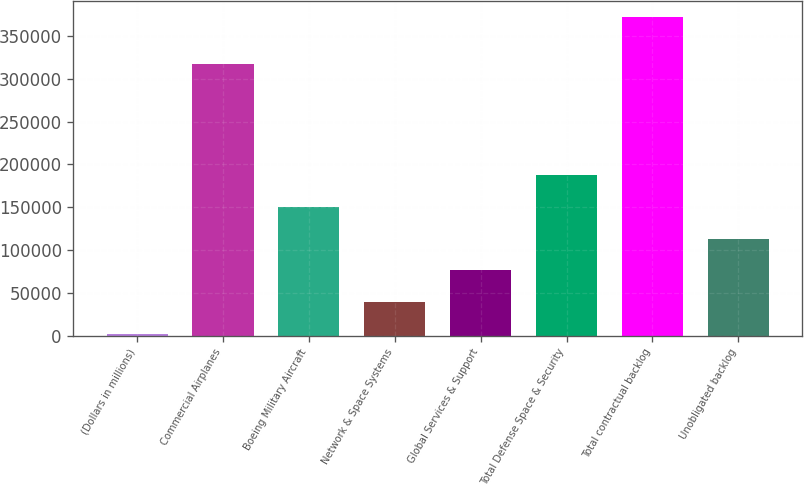Convert chart to OTSL. <chart><loc_0><loc_0><loc_500><loc_500><bar_chart><fcel>(Dollars in millions)<fcel>Commercial Airplanes<fcel>Boeing Military Aircraft<fcel>Network & Space Systems<fcel>Global Services & Support<fcel>Total Defense Space & Security<fcel>Total contractual backlog<fcel>Unobligated backlog<nl><fcel>2012<fcel>317287<fcel>150149<fcel>39046.3<fcel>76080.6<fcel>187184<fcel>372355<fcel>113115<nl></chart> 